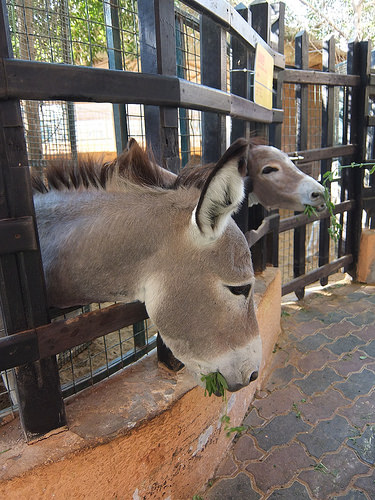<image>
Is there a donkey in the cage? Yes. The donkey is contained within or inside the cage, showing a containment relationship. 